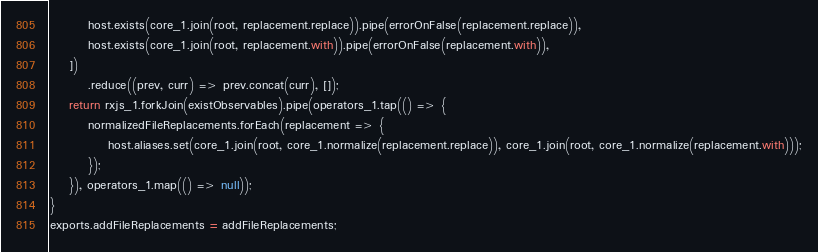Convert code to text. <code><loc_0><loc_0><loc_500><loc_500><_JavaScript_>        host.exists(core_1.join(root, replacement.replace)).pipe(errorOnFalse(replacement.replace)),
        host.exists(core_1.join(root, replacement.with)).pipe(errorOnFalse(replacement.with)),
    ])
        .reduce((prev, curr) => prev.concat(curr), []);
    return rxjs_1.forkJoin(existObservables).pipe(operators_1.tap(() => {
        normalizedFileReplacements.forEach(replacement => {
            host.aliases.set(core_1.join(root, core_1.normalize(replacement.replace)), core_1.join(root, core_1.normalize(replacement.with)));
        });
    }), operators_1.map(() => null));
}
exports.addFileReplacements = addFileReplacements;</code> 